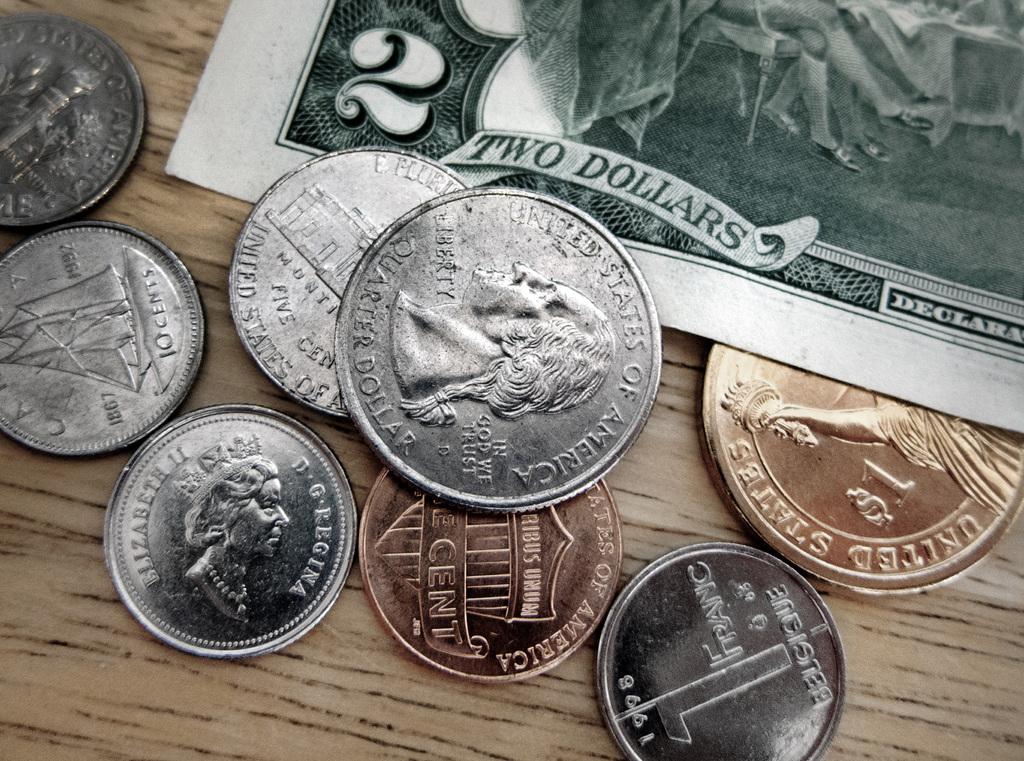How much is the bill here worth?
Ensure brevity in your answer.  Two dollars. How much is the coin in the center worth?
Your answer should be compact. Quarter dollar. 